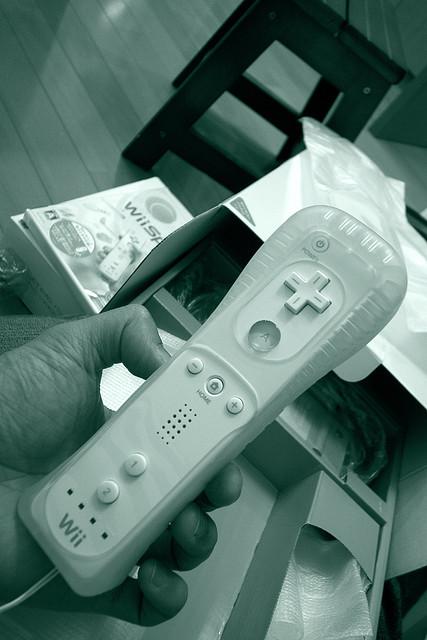What game is beside the box?
Concise answer only. Wii sports. What brand of device is this?
Quick response, please. Wii. Is this a phone?
Quick response, please. No. Is that a TV remote?
Keep it brief. No. 